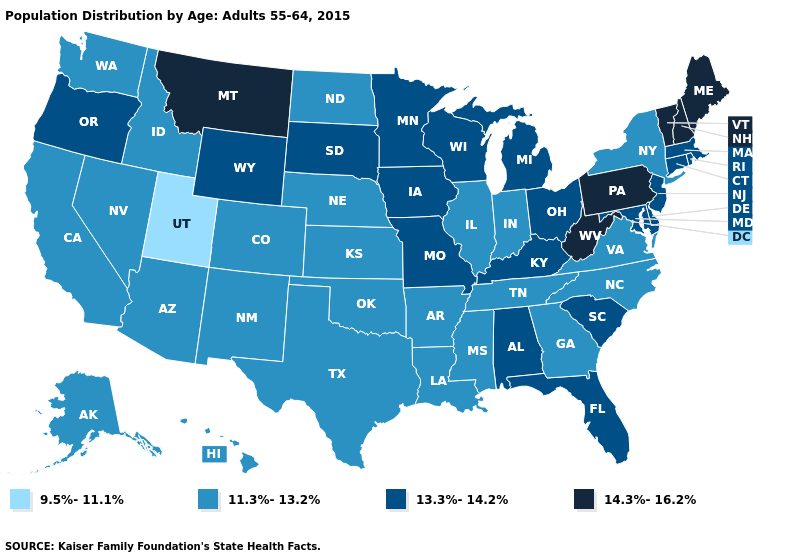What is the lowest value in the USA?
Concise answer only. 9.5%-11.1%. Among the states that border New York , does Vermont have the lowest value?
Keep it brief. No. Name the states that have a value in the range 13.3%-14.2%?
Write a very short answer. Alabama, Connecticut, Delaware, Florida, Iowa, Kentucky, Maryland, Massachusetts, Michigan, Minnesota, Missouri, New Jersey, Ohio, Oregon, Rhode Island, South Carolina, South Dakota, Wisconsin, Wyoming. Which states hav the highest value in the MidWest?
Write a very short answer. Iowa, Michigan, Minnesota, Missouri, Ohio, South Dakota, Wisconsin. What is the lowest value in states that border Montana?
Concise answer only. 11.3%-13.2%. What is the highest value in the MidWest ?
Short answer required. 13.3%-14.2%. Does the map have missing data?
Short answer required. No. What is the value of Colorado?
Keep it brief. 11.3%-13.2%. What is the value of Missouri?
Be succinct. 13.3%-14.2%. Does Minnesota have the same value as Florida?
Give a very brief answer. Yes. Name the states that have a value in the range 9.5%-11.1%?
Quick response, please. Utah. What is the highest value in the USA?
Be succinct. 14.3%-16.2%. What is the highest value in states that border Ohio?
Give a very brief answer. 14.3%-16.2%. Among the states that border Maine , which have the highest value?
Write a very short answer. New Hampshire. What is the lowest value in states that border Colorado?
Concise answer only. 9.5%-11.1%. 